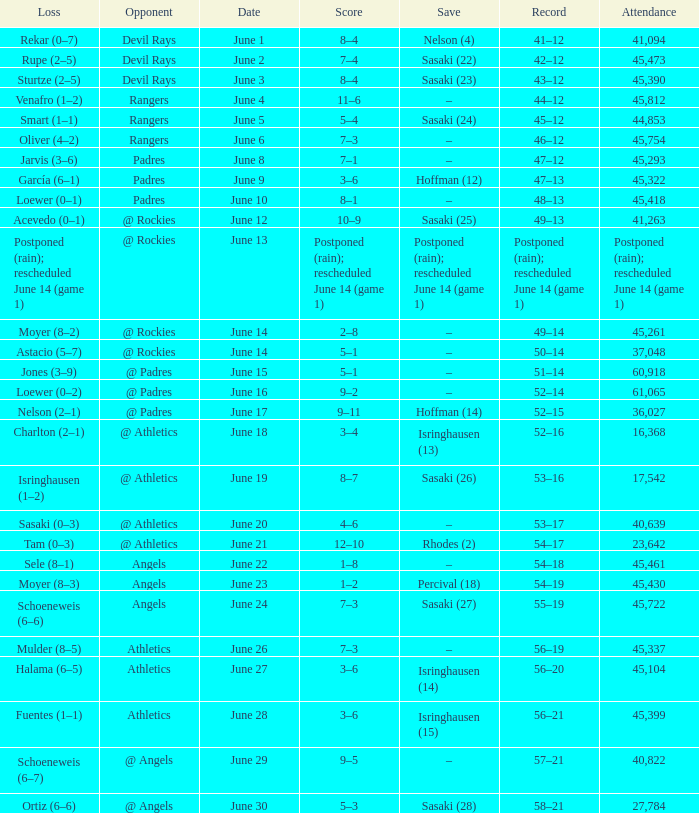What was the attendance of the Mariners game when they had a record of 56–20? 45104.0. 